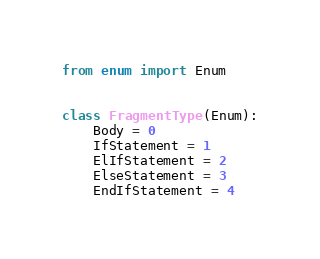<code> <loc_0><loc_0><loc_500><loc_500><_Python_>from enum import Enum


class FragmentType(Enum):
    Body = 0
    IfStatement = 1
    ElIfStatement = 2
    ElseStatement = 3
    EndIfStatement = 4
</code> 